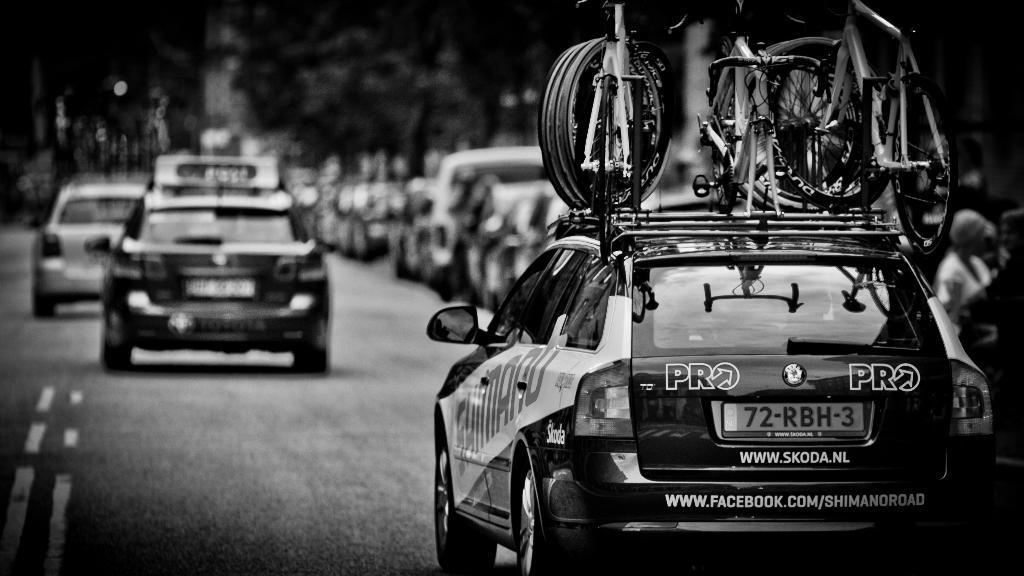Describe this image in one or two sentences. This is a black and white picture. I can see vehicles on the road, there are bicycles on the car, and there is blur background. 